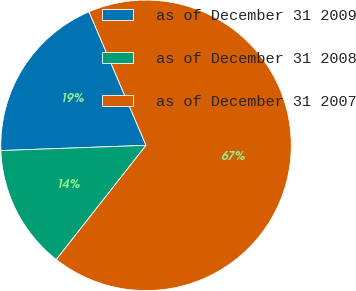<chart> <loc_0><loc_0><loc_500><loc_500><pie_chart><fcel>as of December 31 2009<fcel>as of December 31 2008<fcel>as of December 31 2007<nl><fcel>19.15%<fcel>13.83%<fcel>67.02%<nl></chart> 